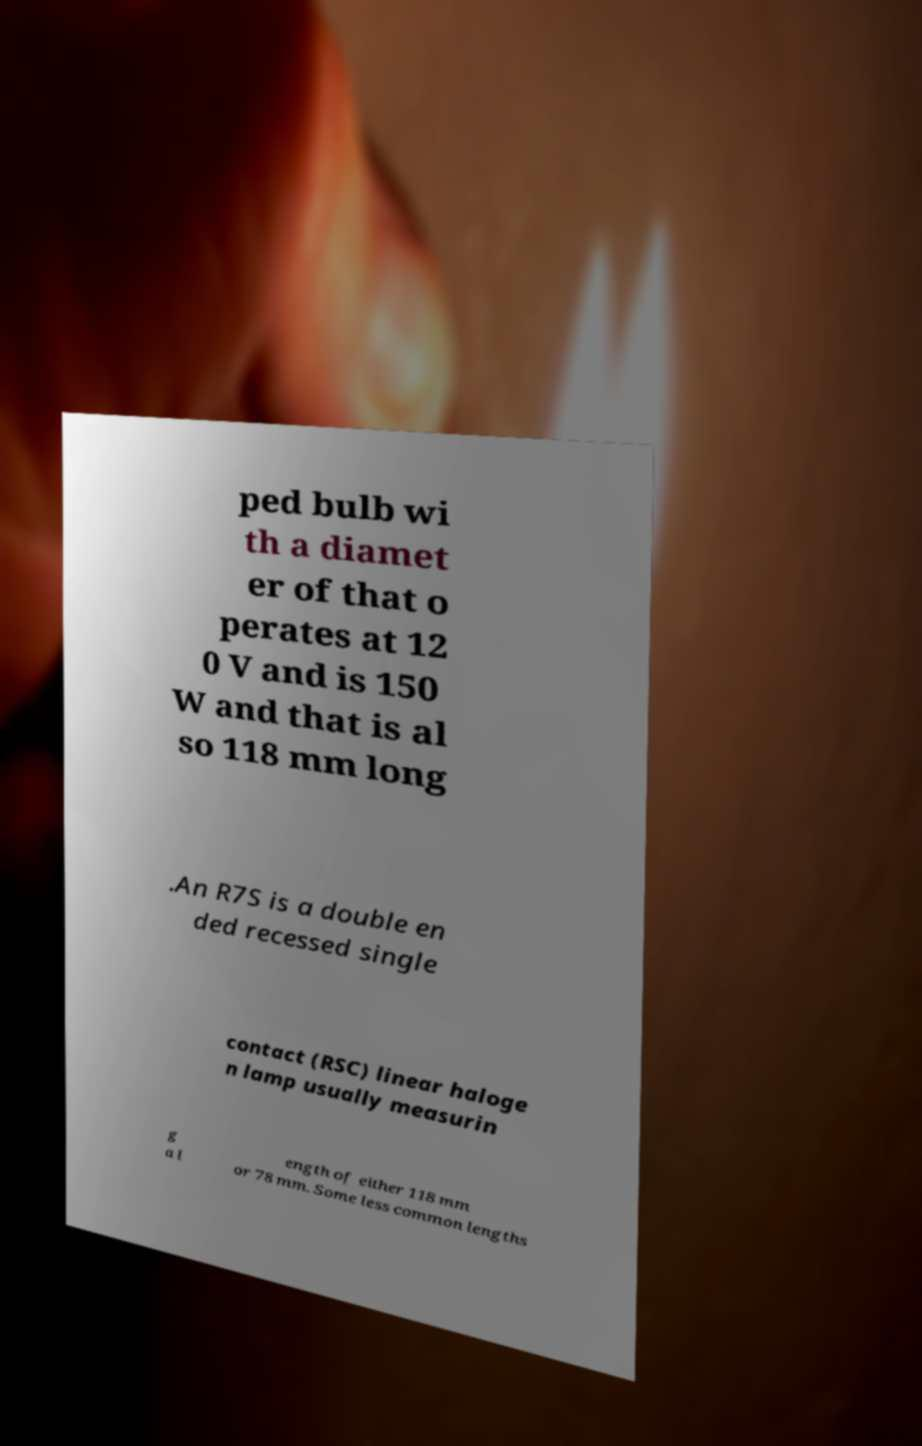Can you read and provide the text displayed in the image?This photo seems to have some interesting text. Can you extract and type it out for me? ped bulb wi th a diamet er of that o perates at 12 0 V and is 150 W and that is al so 118 mm long .An R7S is a double en ded recessed single contact (RSC) linear haloge n lamp usually measurin g a l ength of either 118 mm or 78 mm. Some less common lengths 